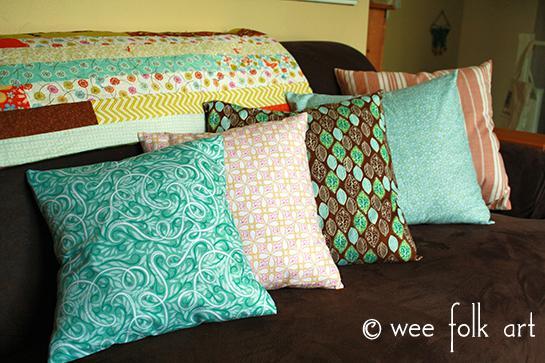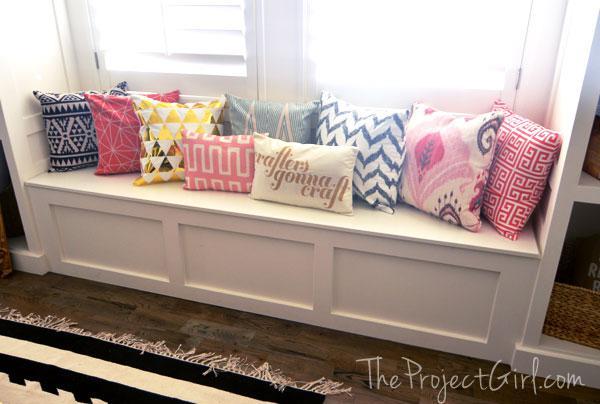The first image is the image on the left, the second image is the image on the right. For the images shown, is this caption "A brown sofa holds two pillows decorated with round doily shapes on a dark background." true? Answer yes or no. No. The first image is the image on the left, the second image is the image on the right. For the images shown, is this caption "The left image contains at least five pillows." true? Answer yes or no. Yes. 